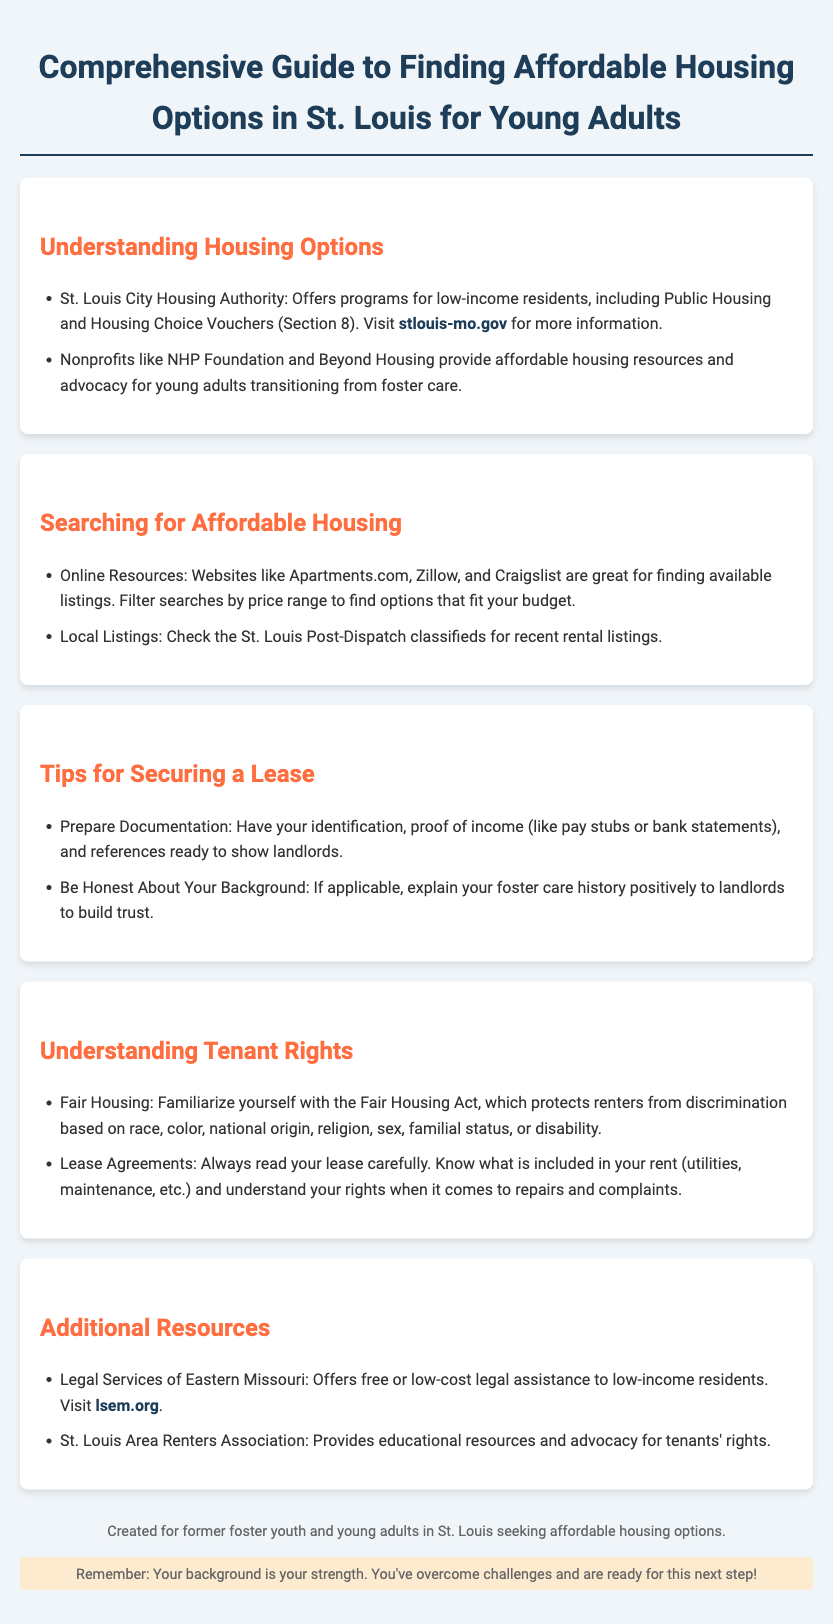What programs does the St. Louis City Housing Authority offer? The document states that the St. Louis City Housing Authority offers Public Housing and Housing Choice Vouchers (Section 8).
Answer: Public Housing and Housing Choice Vouchers (Section 8) What organizations provide housing resources for young adults transitioning from foster care? The document mentions nonprofits such as NHP Foundation and Beyond Housing.
Answer: NHP Foundation and Beyond Housing Where can you find online listings for affordable housing? The document lists Apartments.com, Zillow, and Craigslist as great sources for finding listings.
Answer: Apartments.com, Zillow, and Craigslist What should you have ready to show landlords when securing a lease? The document advises having identification, proof of income, and references prepared.
Answer: Identification, proof of income, and references What act protects renters from discrimination? The document refers to the Fair Housing Act as the legislation that provides this protection.
Answer: Fair Housing Act What is the focus of the additional resources section? The additional resources section provides information on legal assistance and tenants' rights advocacy.
Answer: Legal assistance and tenants' rights advocacy What is a key tip for being honest with landlords? The document suggests explaining your foster care history positively to build trust with landlords.
Answer: Explain your foster care history positively What does the document highlight as a strength for former foster youth? The document emphasizes that overcoming challenges is a strength for those transitioning into housing.
Answer: Your background is your strength How often should you read your lease? The document recommends reading the lease carefully every time you sign or renew it.
Answer: Always read your lease carefully 